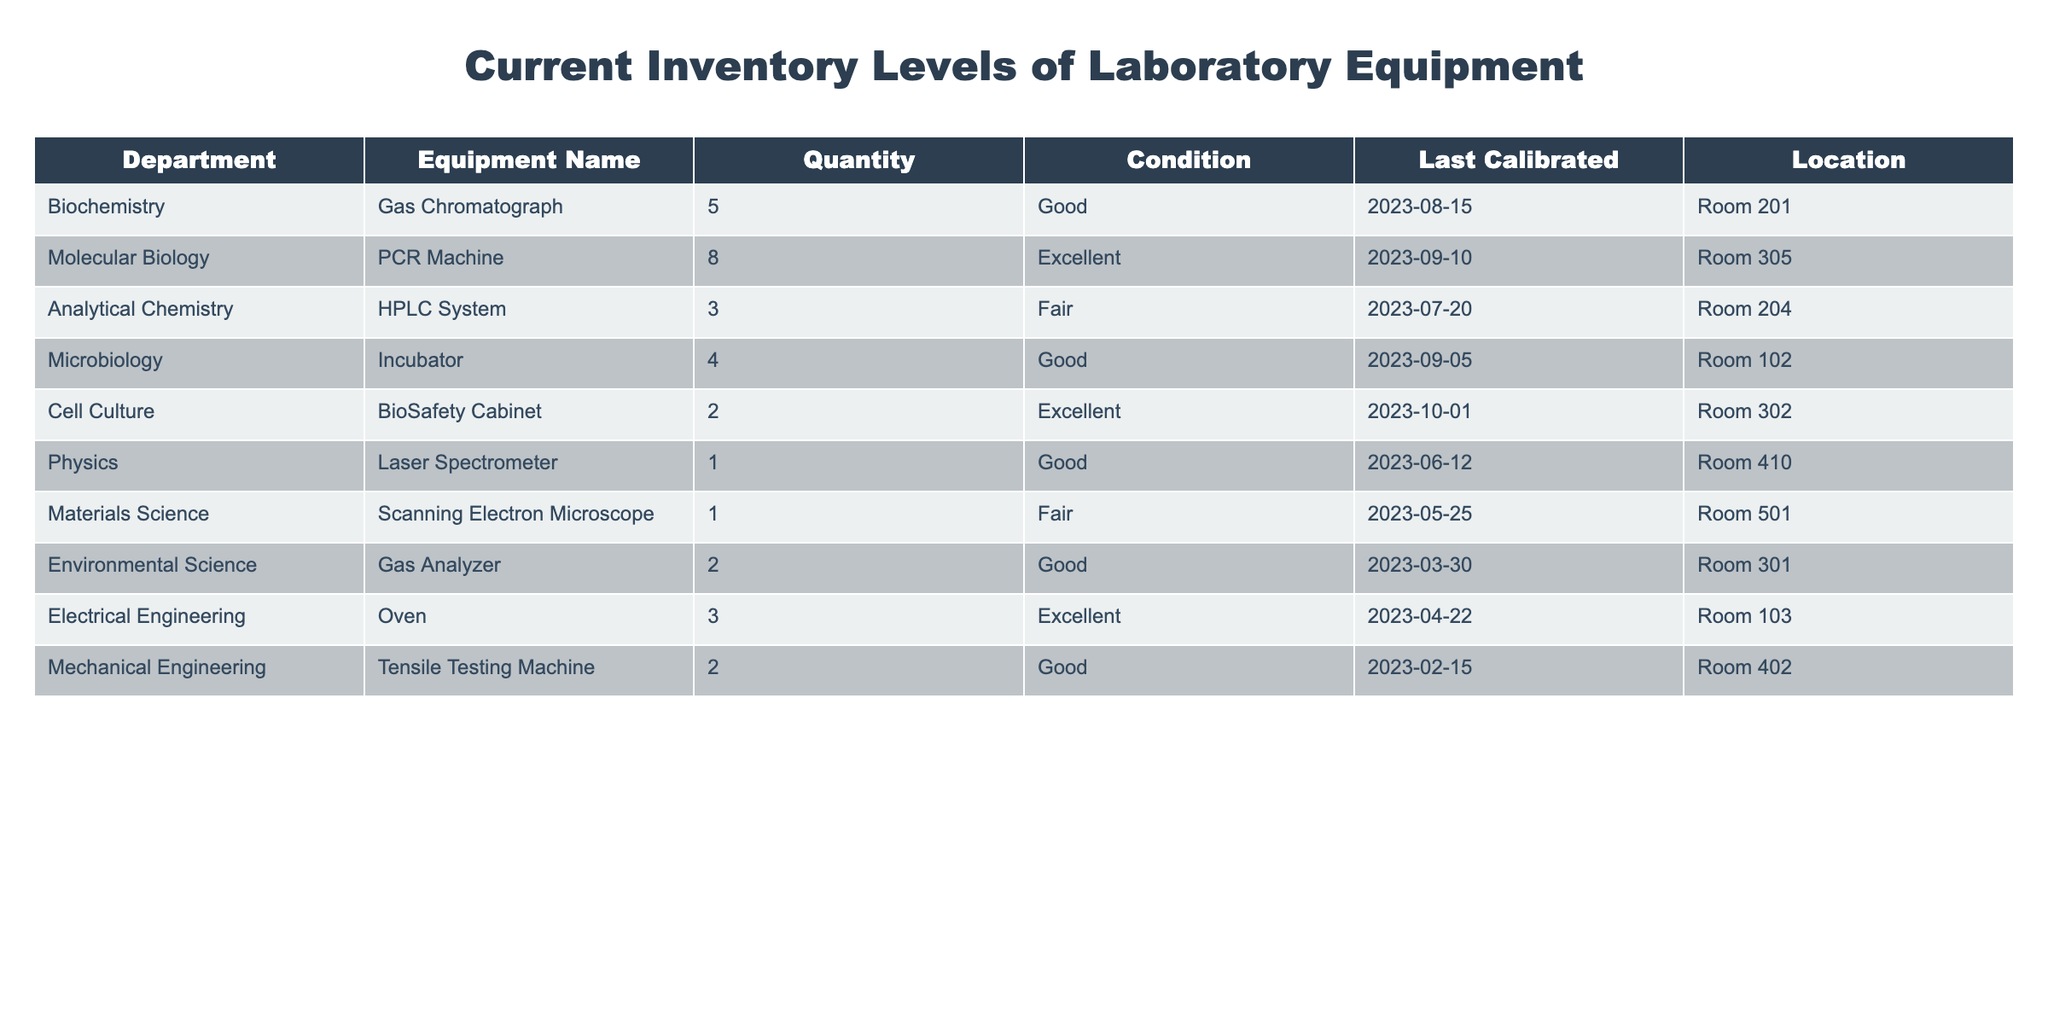What is the total quantity of equipment available in the Biochemistry department? The Biochemistry department has one type of equipment listed in the table, the Gas Chromatograph, with a quantity of 5. Therefore, the total quantity is simply 5.
Answer: 5 Which department has the least amount of equipment? The departments are listed with their respective quantities. The Physics and Materials Science departments each have only 1 piece of equipment. Since both have the same quantity, they tie for the least amount of equipment.
Answer: Physics and Materials Science How many pieces of equipment in total are in the inventory table? To find the total, we need to sum the quantities of all equipment listed in the table: 5 (Biochemistry) + 8 (Molecular Biology) + 3 (Analytical Chemistry) + 4 (Microbiology) + 2 (Cell Culture) + 1 (Physics) + 1 (Materials Science) + 2 (Environmental Science) + 3 (Electrical Engineering) + 2 (Mechanical Engineering) = 31.
Answer: 31 Is there any equipment in "Fair" condition in the Electrical Engineering department? The table indicates that the Electric Engineering department has an Oven in "Excellent" condition. Therefore, there are no pieces of equipment in "Fair" condition within this department.
Answer: No What is the average quantity of equipment across all departments listed? To calculate the average, we first find the total quantity, which is 31 (as calculated previously), and then divide by the number of departments, which is 10. Therefore, the average is 31/10 = 3.1.
Answer: 3.1 Which department has the highest quantity of equipment? By examining the table, the Molecular Biology department, with 8 PCR Machines listed, has the highest quantity of any single piece of equipment. Thus, the highest quantity belongs to this department.
Answer: Molecular Biology How many departments have equipment that is in "Good" condition? By looking at the table, we see the following departments with equipment in "Good" condition: Biochemistry (Gas Chromatograph), Microbiology (Incubator), Environmental Science (Gas Analyzer), and Mechanical Engineering (Tensile Testing Machine), totaling 4 departments.
Answer: 4 Are there any departments with multiple types of equipment listed? Upon reviewing the table, each department is associated with only one type of equipment. Hence, there are no departments that have multiple types of equipment listed.
Answer: No 